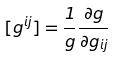<formula> <loc_0><loc_0><loc_500><loc_500>[ g ^ { i j } ] = \frac { 1 } { g } \frac { \partial g } { \partial g _ { i j } }</formula> 